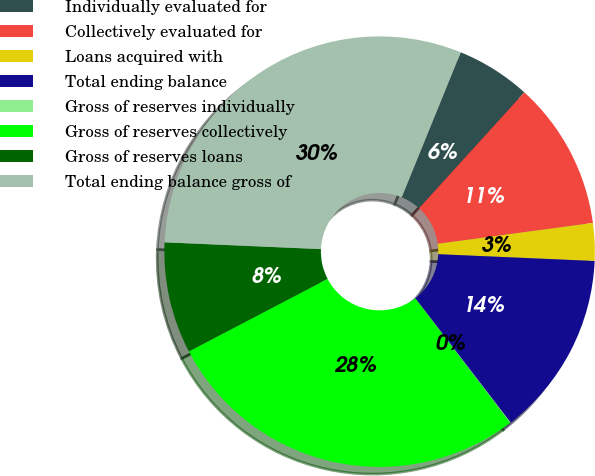Convert chart to OTSL. <chart><loc_0><loc_0><loc_500><loc_500><pie_chart><fcel>Individually evaluated for<fcel>Collectively evaluated for<fcel>Loans acquired with<fcel>Total ending balance<fcel>Gross of reserves individually<fcel>Gross of reserves collectively<fcel>Gross of reserves loans<fcel>Total ending balance gross of<nl><fcel>5.59%<fcel>11.13%<fcel>2.82%<fcel>13.9%<fcel>0.05%<fcel>27.69%<fcel>8.36%<fcel>30.46%<nl></chart> 